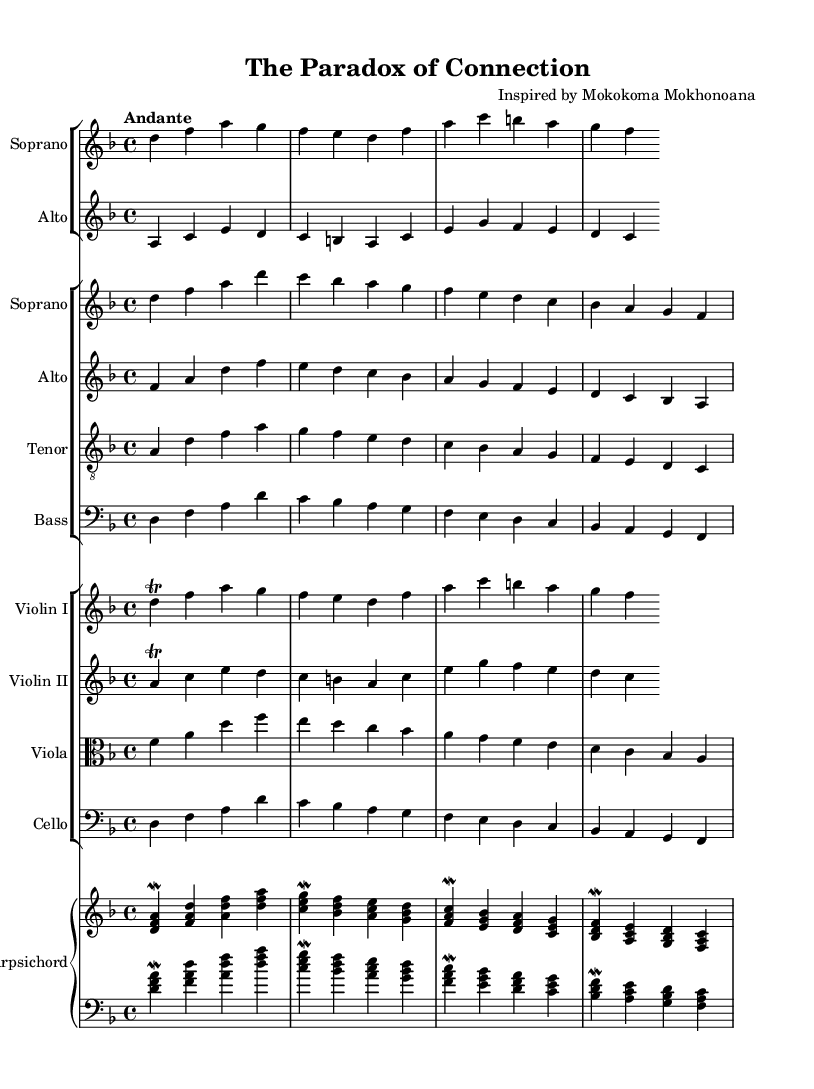What is the key signature of this music? The key signature is indicated by the symbols at the beginning of the staff. Here, the key signature shows one flat (B), which corresponds to D minor.
Answer: D minor What is the time signature of this music? The time signature is displayed as a fraction at the beginning of the sheet, where 4 over 4 indicates that each measure contains four beats and the quarter note receives one beat.
Answer: 4/4 What is the tempo marking of this music? The tempo marking is specified within the score, where "Andante" indicates a moderately slow tempo.
Answer: Andante How many vocal parts are there in the choir staff? The choir staff shows four distinct staves, each representing a vocal part: soprano, alto, tenor, and bass. Counting these gives the total number of parts.
Answer: Four What instrument is indicated for the harpsichord? The harpsichord is noted in the score, and the specific instruction is given by the staff labelled with "Harpsichord." This identifies the instrument clearly.
Answer: Harpsichord Which vocal part has the lyrics "In this vast world of faces and names"? The lyrics associated with this phrase are indicated directly below the staff for the soprano solo, where the corresponding lyrics appear.
Answer: Soprano What is the thematic focus of the lyrics in this oratorio? The lyrics explore the complexity of human connections and social dynamics, evident from lines like "yearning for closeness, yet afraid to give," which highlight these themes.
Answer: Connection 